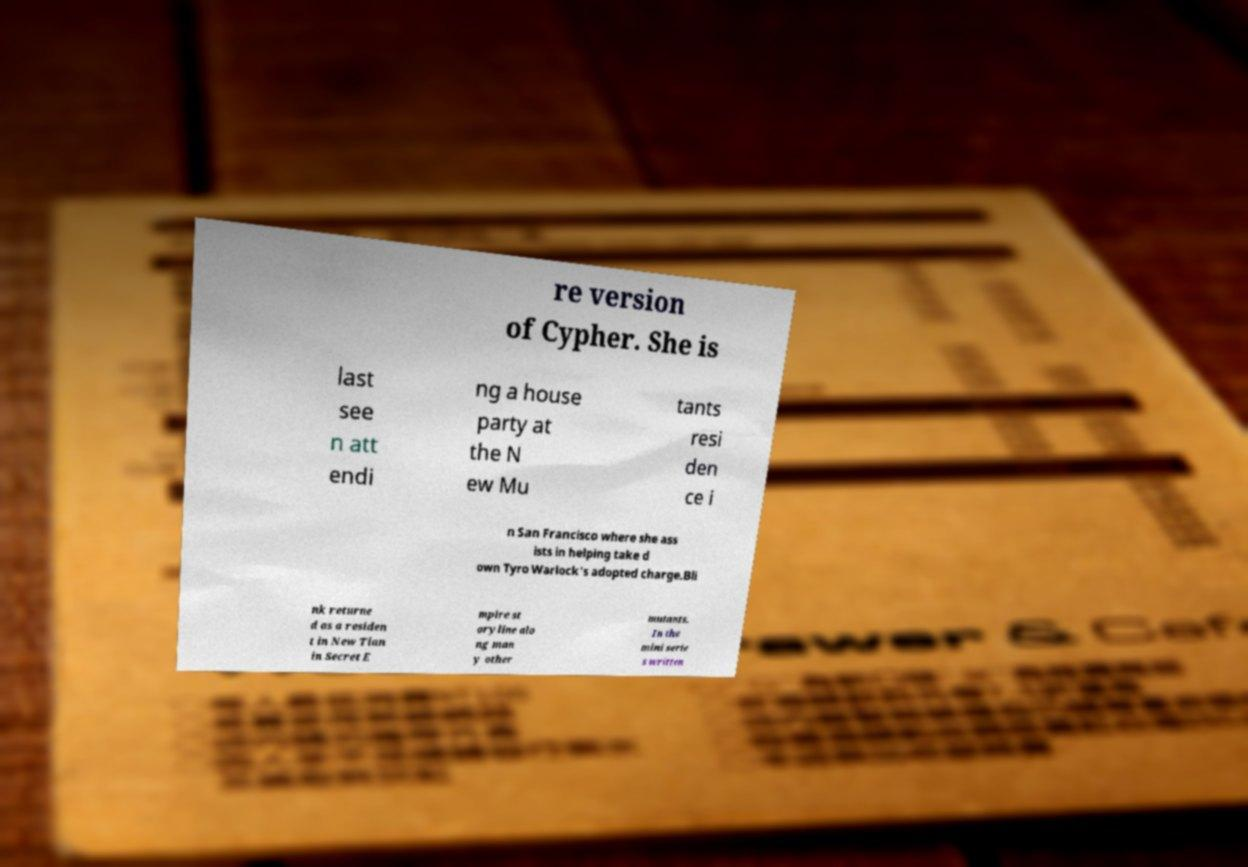Could you assist in decoding the text presented in this image and type it out clearly? re version of Cypher. She is last see n att endi ng a house party at the N ew Mu tants resi den ce i n San Francisco where she ass ists in helping take d own Tyro Warlock's adopted charge.Bli nk returne d as a residen t in New Tian in Secret E mpire st oryline alo ng man y other mutants. In the mini serie s written 